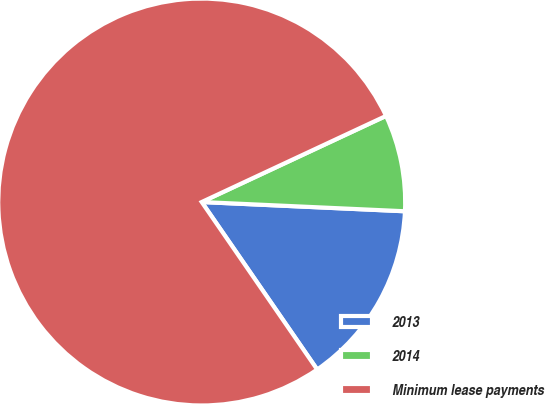Convert chart. <chart><loc_0><loc_0><loc_500><loc_500><pie_chart><fcel>2013<fcel>2014<fcel>Minimum lease payments<nl><fcel>14.67%<fcel>7.68%<fcel>77.65%<nl></chart> 